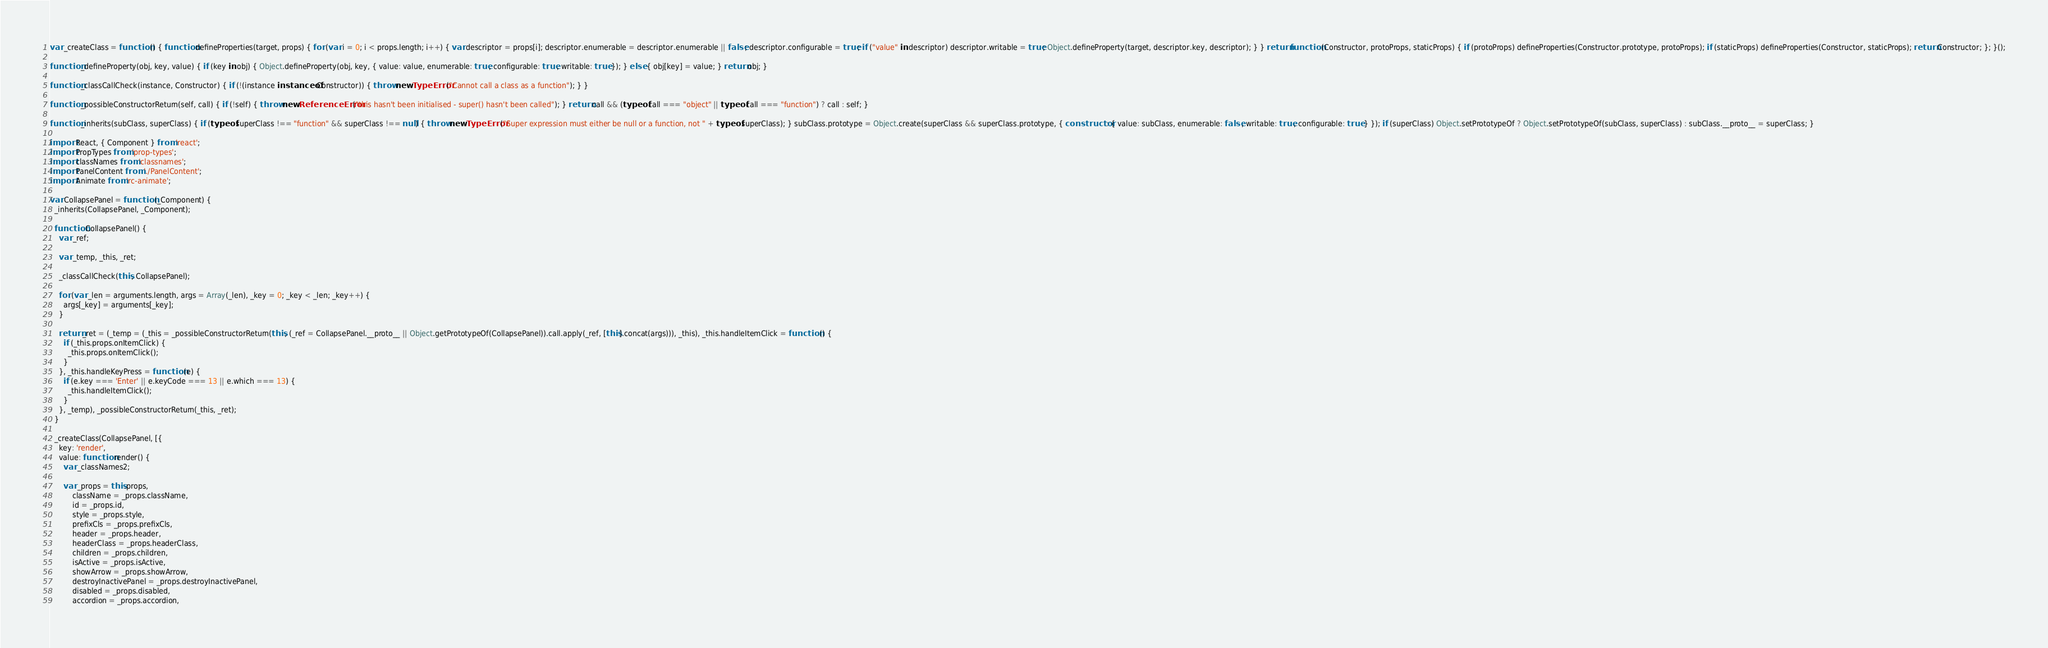<code> <loc_0><loc_0><loc_500><loc_500><_JavaScript_>var _createClass = function () { function defineProperties(target, props) { for (var i = 0; i < props.length; i++) { var descriptor = props[i]; descriptor.enumerable = descriptor.enumerable || false; descriptor.configurable = true; if ("value" in descriptor) descriptor.writable = true; Object.defineProperty(target, descriptor.key, descriptor); } } return function (Constructor, protoProps, staticProps) { if (protoProps) defineProperties(Constructor.prototype, protoProps); if (staticProps) defineProperties(Constructor, staticProps); return Constructor; }; }();

function _defineProperty(obj, key, value) { if (key in obj) { Object.defineProperty(obj, key, { value: value, enumerable: true, configurable: true, writable: true }); } else { obj[key] = value; } return obj; }

function _classCallCheck(instance, Constructor) { if (!(instance instanceof Constructor)) { throw new TypeError("Cannot call a class as a function"); } }

function _possibleConstructorReturn(self, call) { if (!self) { throw new ReferenceError("this hasn't been initialised - super() hasn't been called"); } return call && (typeof call === "object" || typeof call === "function") ? call : self; }

function _inherits(subClass, superClass) { if (typeof superClass !== "function" && superClass !== null) { throw new TypeError("Super expression must either be null or a function, not " + typeof superClass); } subClass.prototype = Object.create(superClass && superClass.prototype, { constructor: { value: subClass, enumerable: false, writable: true, configurable: true } }); if (superClass) Object.setPrototypeOf ? Object.setPrototypeOf(subClass, superClass) : subClass.__proto__ = superClass; }

import React, { Component } from 'react';
import PropTypes from 'prop-types';
import classNames from 'classnames';
import PanelContent from './PanelContent';
import Animate from 'rc-animate';

var CollapsePanel = function (_Component) {
  _inherits(CollapsePanel, _Component);

  function CollapsePanel() {
    var _ref;

    var _temp, _this, _ret;

    _classCallCheck(this, CollapsePanel);

    for (var _len = arguments.length, args = Array(_len), _key = 0; _key < _len; _key++) {
      args[_key] = arguments[_key];
    }

    return _ret = (_temp = (_this = _possibleConstructorReturn(this, (_ref = CollapsePanel.__proto__ || Object.getPrototypeOf(CollapsePanel)).call.apply(_ref, [this].concat(args))), _this), _this.handleItemClick = function () {
      if (_this.props.onItemClick) {
        _this.props.onItemClick();
      }
    }, _this.handleKeyPress = function (e) {
      if (e.key === 'Enter' || e.keyCode === 13 || e.which === 13) {
        _this.handleItemClick();
      }
    }, _temp), _possibleConstructorReturn(_this, _ret);
  }

  _createClass(CollapsePanel, [{
    key: 'render',
    value: function render() {
      var _classNames2;

      var _props = this.props,
          className = _props.className,
          id = _props.id,
          style = _props.style,
          prefixCls = _props.prefixCls,
          header = _props.header,
          headerClass = _props.headerClass,
          children = _props.children,
          isActive = _props.isActive,
          showArrow = _props.showArrow,
          destroyInactivePanel = _props.destroyInactivePanel,
          disabled = _props.disabled,
          accordion = _props.accordion,</code> 